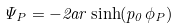<formula> <loc_0><loc_0><loc_500><loc_500>\Psi _ { P } = - 2 a r \sinh ( p _ { 0 } \phi _ { P } )</formula> 